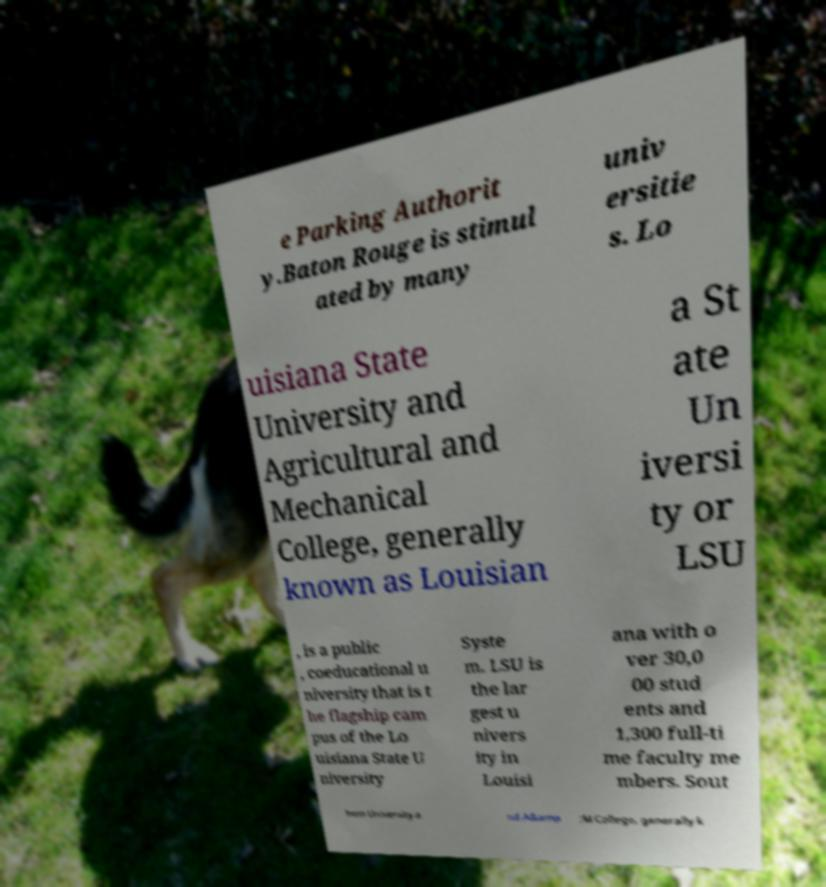Please read and relay the text visible in this image. What does it say? e Parking Authorit y.Baton Rouge is stimul ated by many univ ersitie s. Lo uisiana State University and Agricultural and Mechanical College, generally known as Louisian a St ate Un iversi ty or LSU , is a public , coeducational u niversity that is t he flagship cam pus of the Lo uisiana State U niversity Syste m. LSU is the lar gest u nivers ity in Louisi ana with o ver 30,0 00 stud ents and 1,300 full-ti me faculty me mbers. Sout hern University a nd A&amp ;M College, generally k 